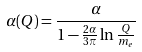Convert formula to latex. <formula><loc_0><loc_0><loc_500><loc_500>\alpha ( Q ) = \frac { \alpha } { 1 - \frac { 2 \alpha } { 3 \pi } \ln \frac { Q } { m _ { e } } }</formula> 